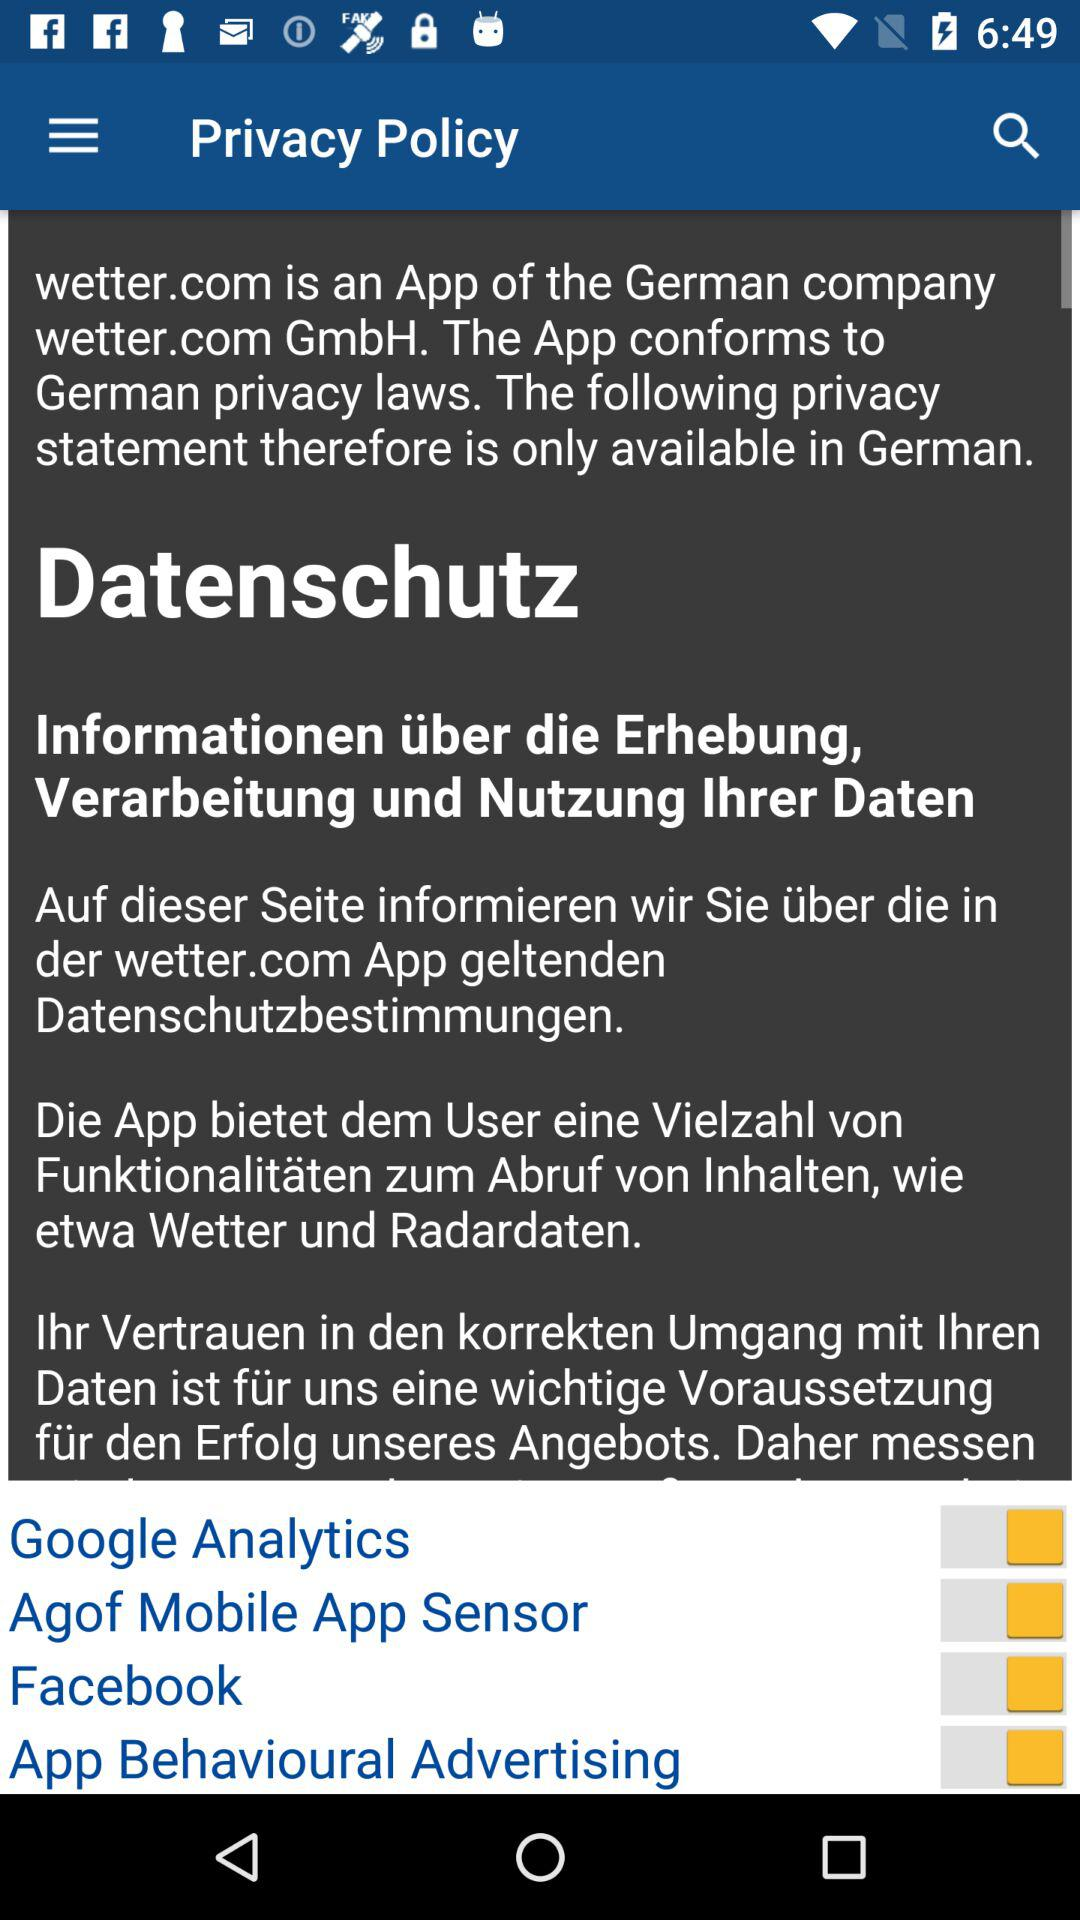How many switches are there in the privacy policy?
Answer the question using a single word or phrase. 4 